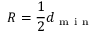<formula> <loc_0><loc_0><loc_500><loc_500>R = \frac { 1 } { 2 } d _ { m i n }</formula> 